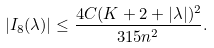<formula> <loc_0><loc_0><loc_500><loc_500>| I _ { 8 } ( \lambda ) | \leq \frac { 4 C ( K + 2 + | \lambda | ) ^ { 2 } } { 3 1 5 n ^ { 2 } } .</formula> 